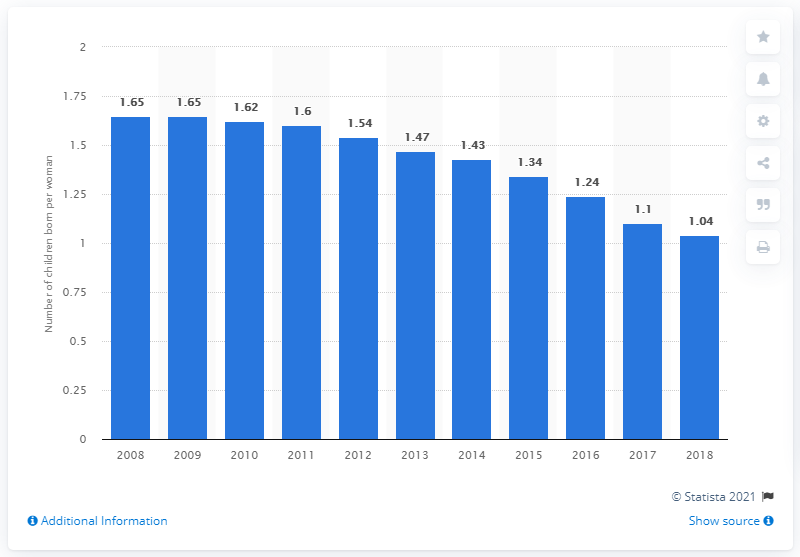Draw attention to some important aspects in this diagram. The fertility rate in Puerto Rico in 2018 was 1.04. 